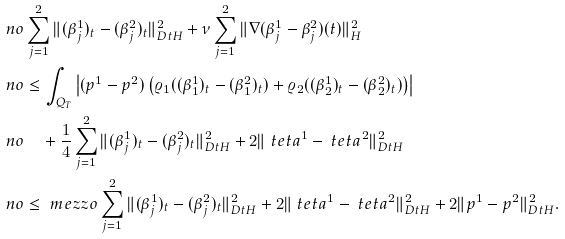Convert formula to latex. <formula><loc_0><loc_0><loc_500><loc_500>\ n o & \sum _ { j = 1 } ^ { 2 } \| ( \beta _ { j } ^ { 1 } ) _ { t } - ( \beta _ { j } ^ { 2 } ) _ { t } \| _ { \L D t H } ^ { 2 } + \nu \sum _ { j = 1 } ^ { 2 } \| \nabla ( \beta _ { j } ^ { 1 } - \beta _ { j } ^ { 2 } ) ( t ) \| _ { H } ^ { 2 } \\ \ n o & \leq \int _ { Q _ { T } } \left | ( p ^ { 1 } - p ^ { 2 } ) \left ( \varrho _ { 1 } ( ( \beta _ { 1 } ^ { 1 } ) _ { t } - ( \beta _ { 1 } ^ { 2 } ) _ { t } ) + \varrho _ { 2 } ( ( \beta _ { 2 } ^ { 1 } ) _ { t } - ( \beta _ { 2 } ^ { 2 } ) _ { t } ) \right ) \right | \\ \ n o & \quad + \frac { 1 } { 4 } \sum _ { j = 1 } ^ { 2 } \| ( \beta _ { j } ^ { 1 } ) _ { t } - ( \beta _ { j } ^ { 2 } ) _ { t } \| _ { \L D t H } ^ { 2 } + 2 \| \ t e t a ^ { 1 } - \ t e t a ^ { 2 } \| _ { \L D t H } ^ { 2 } \\ \ n o & \leq \ m e z z o \sum _ { j = 1 } ^ { 2 } \| ( \beta _ { j } ^ { 1 } ) _ { t } - ( \beta _ { j } ^ { 2 } ) _ { t } \| _ { \L D t H } ^ { 2 } + 2 \| \ t e t a ^ { 1 } - \ t e t a ^ { 2 } \| _ { \L D t H } ^ { 2 } + 2 \| p ^ { 1 } - p ^ { 2 } \| _ { \L D t H } ^ { 2 } .</formula> 